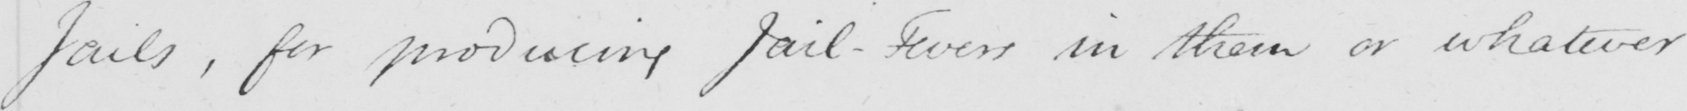Please provide the text content of this handwritten line. Jails , for producing Jail-Fevers in them or whatever 